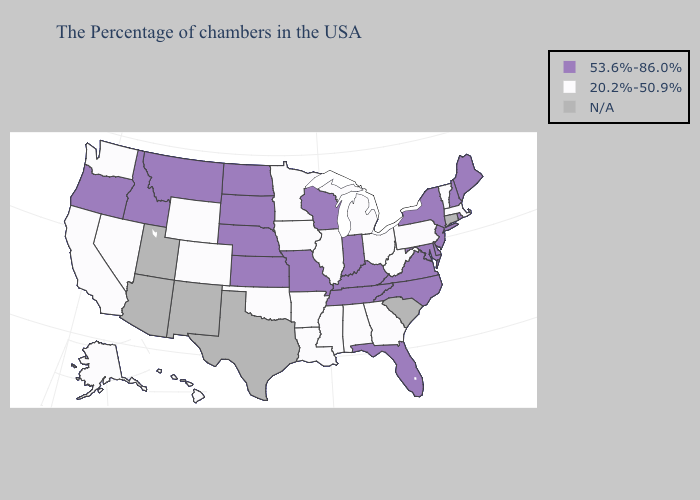Name the states that have a value in the range 20.2%-50.9%?
Answer briefly. Massachusetts, Vermont, Pennsylvania, West Virginia, Ohio, Georgia, Michigan, Alabama, Illinois, Mississippi, Louisiana, Arkansas, Minnesota, Iowa, Oklahoma, Wyoming, Colorado, Nevada, California, Washington, Alaska, Hawaii. Which states have the lowest value in the Northeast?
Write a very short answer. Massachusetts, Vermont, Pennsylvania. Does Florida have the highest value in the USA?
Answer briefly. Yes. Which states have the lowest value in the West?
Concise answer only. Wyoming, Colorado, Nevada, California, Washington, Alaska, Hawaii. Does Nevada have the highest value in the West?
Give a very brief answer. No. Name the states that have a value in the range 53.6%-86.0%?
Write a very short answer. Maine, Rhode Island, New Hampshire, New York, New Jersey, Delaware, Maryland, Virginia, North Carolina, Florida, Kentucky, Indiana, Tennessee, Wisconsin, Missouri, Kansas, Nebraska, South Dakota, North Dakota, Montana, Idaho, Oregon. What is the lowest value in the USA?
Quick response, please. 20.2%-50.9%. What is the lowest value in the South?
Be succinct. 20.2%-50.9%. What is the value of Kentucky?
Concise answer only. 53.6%-86.0%. Does the map have missing data?
Give a very brief answer. Yes. Does Kansas have the highest value in the MidWest?
Keep it brief. Yes. Name the states that have a value in the range 53.6%-86.0%?
Concise answer only. Maine, Rhode Island, New Hampshire, New York, New Jersey, Delaware, Maryland, Virginia, North Carolina, Florida, Kentucky, Indiana, Tennessee, Wisconsin, Missouri, Kansas, Nebraska, South Dakota, North Dakota, Montana, Idaho, Oregon. What is the value of North Carolina?
Keep it brief. 53.6%-86.0%. Name the states that have a value in the range 53.6%-86.0%?
Short answer required. Maine, Rhode Island, New Hampshire, New York, New Jersey, Delaware, Maryland, Virginia, North Carolina, Florida, Kentucky, Indiana, Tennessee, Wisconsin, Missouri, Kansas, Nebraska, South Dakota, North Dakota, Montana, Idaho, Oregon. 